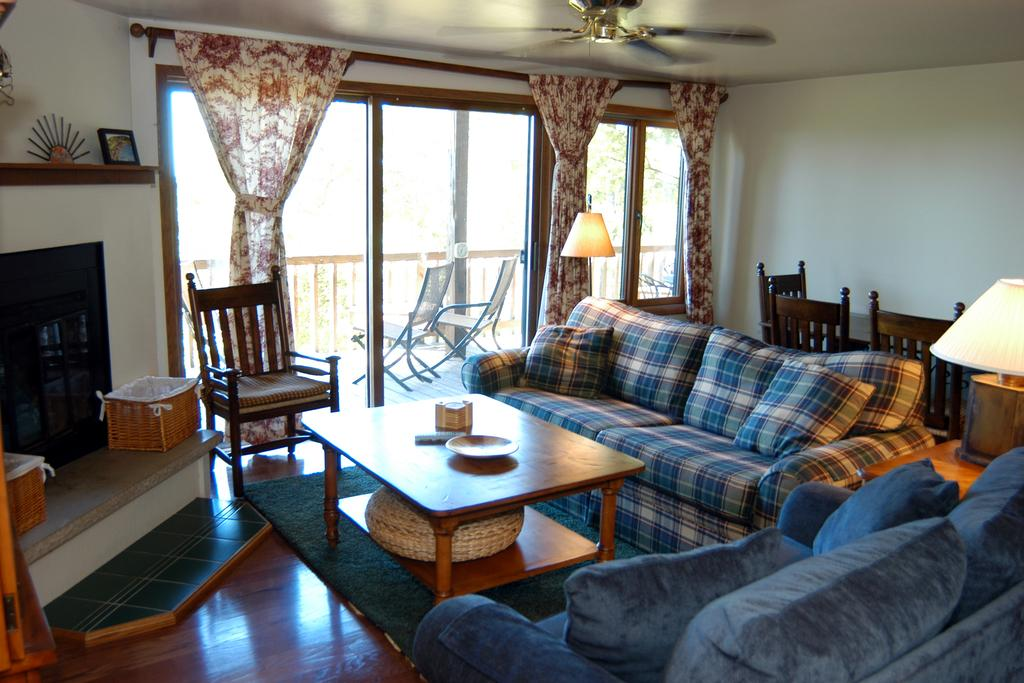What type of furniture is present in the image? There is a sofa, a table, and a chair on the floor in the image. What type of window treatment is visible in the image? There is a curtain in the image. What type of appliance is present in the image? There is a fan in the image. What type of wall color can be seen in the image? There is a white color wall in the image. What type of lighting fixture is present in the image? There is a lamp in the image. What type of heating appliance is present in the image? There is a fireplace on the floor in the image. How many children are playing with the snake in the image? There are no children or snakes present in the image. 